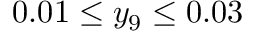Convert formula to latex. <formula><loc_0><loc_0><loc_500><loc_500>0 . 0 1 \leq y _ { 9 } \leq 0 . 0 3</formula> 